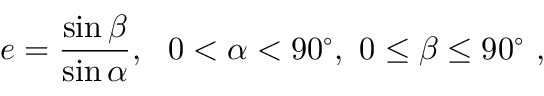<formula> <loc_0><loc_0><loc_500><loc_500>e = { \frac { \sin \beta } { \sin \alpha } } , \ \ 0 < \alpha < 9 0 ^ { \circ } , \ 0 \leq \beta \leq 9 0 ^ { \circ } \ ,</formula> 